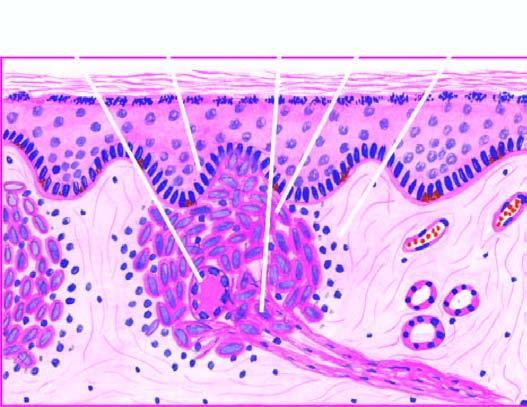what is composed of epithelioid cells with sparse langhans ' giant cells and lymphocytes?
Answer the question using a single word or phrase. Granuloma 